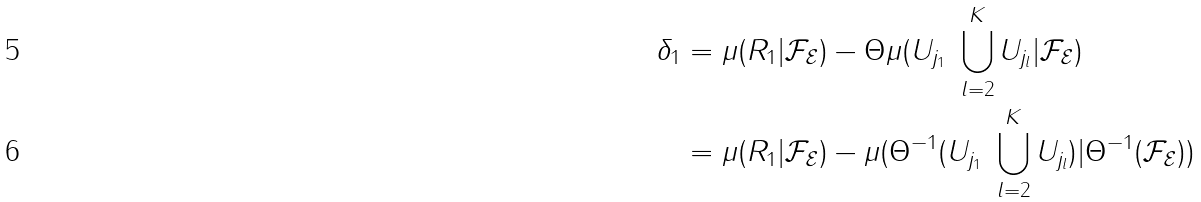<formula> <loc_0><loc_0><loc_500><loc_500>\delta _ { 1 } & = \mu ( R _ { 1 } | \mathcal { F } _ { \mathcal { E } } ) - \Theta \mu ( U _ { j _ { 1 } } \ \bigcup _ { l = 2 } ^ { K } U _ { j _ { l } } | \mathcal { F } _ { \mathcal { E } } ) \\ & = \mu ( R _ { 1 } | \mathcal { F } _ { \mathcal { E } } ) - \mu ( \Theta ^ { - 1 } ( U _ { j _ { 1 } } \ \bigcup _ { l = 2 } ^ { K } U _ { j _ { l } } ) | \Theta ^ { - 1 } ( \mathcal { F } _ { \mathcal { E } } ) )</formula> 